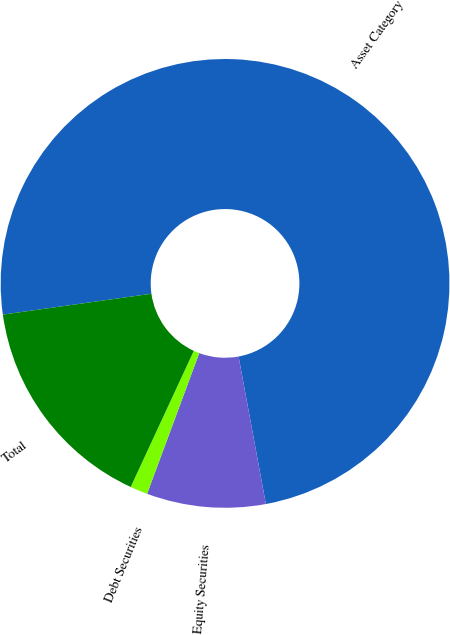<chart> <loc_0><loc_0><loc_500><loc_500><pie_chart><fcel>Asset Category<fcel>Equity Securities<fcel>Debt Securities<fcel>Total<nl><fcel>74.31%<fcel>8.56%<fcel>1.26%<fcel>15.87%<nl></chart> 